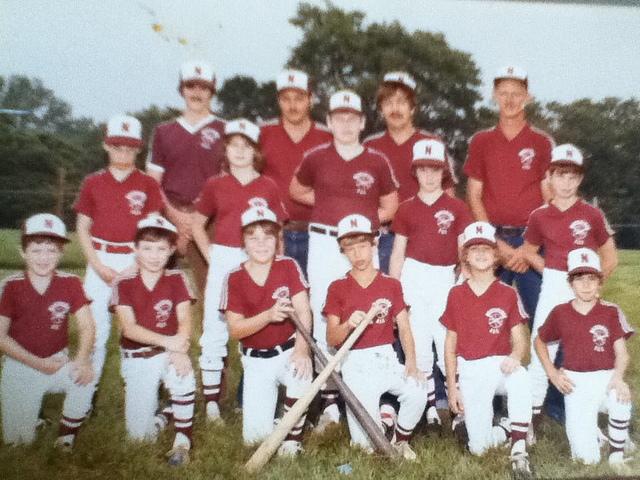What color are the uniforms?
Concise answer only. Red and white. What color are their shirts?
Short answer required. Red. Is the pic black and  white?
Quick response, please. No. How many people are in the picture?
Concise answer only. 15. Is this a professional game?
Write a very short answer. No. What game is this?
Be succinct. Baseball. Are these kids on the same team?
Short answer required. Yes. How many kids are in the first row?
Quick response, please. 6. Is this a recent photo?
Give a very brief answer. No. Is the photo black and white?
Quick response, please. No. Is this a tennis team?
Concise answer only. No. 